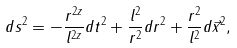Convert formula to latex. <formula><loc_0><loc_0><loc_500><loc_500>d s ^ { 2 } = - \frac { r ^ { 2 z } } { l ^ { 2 z } } d t ^ { 2 } + \frac { l ^ { 2 } } { r ^ { 2 } } d r ^ { 2 } + \frac { r ^ { 2 } } { l ^ { 2 } } d \vec { x } ^ { 2 } ,</formula> 